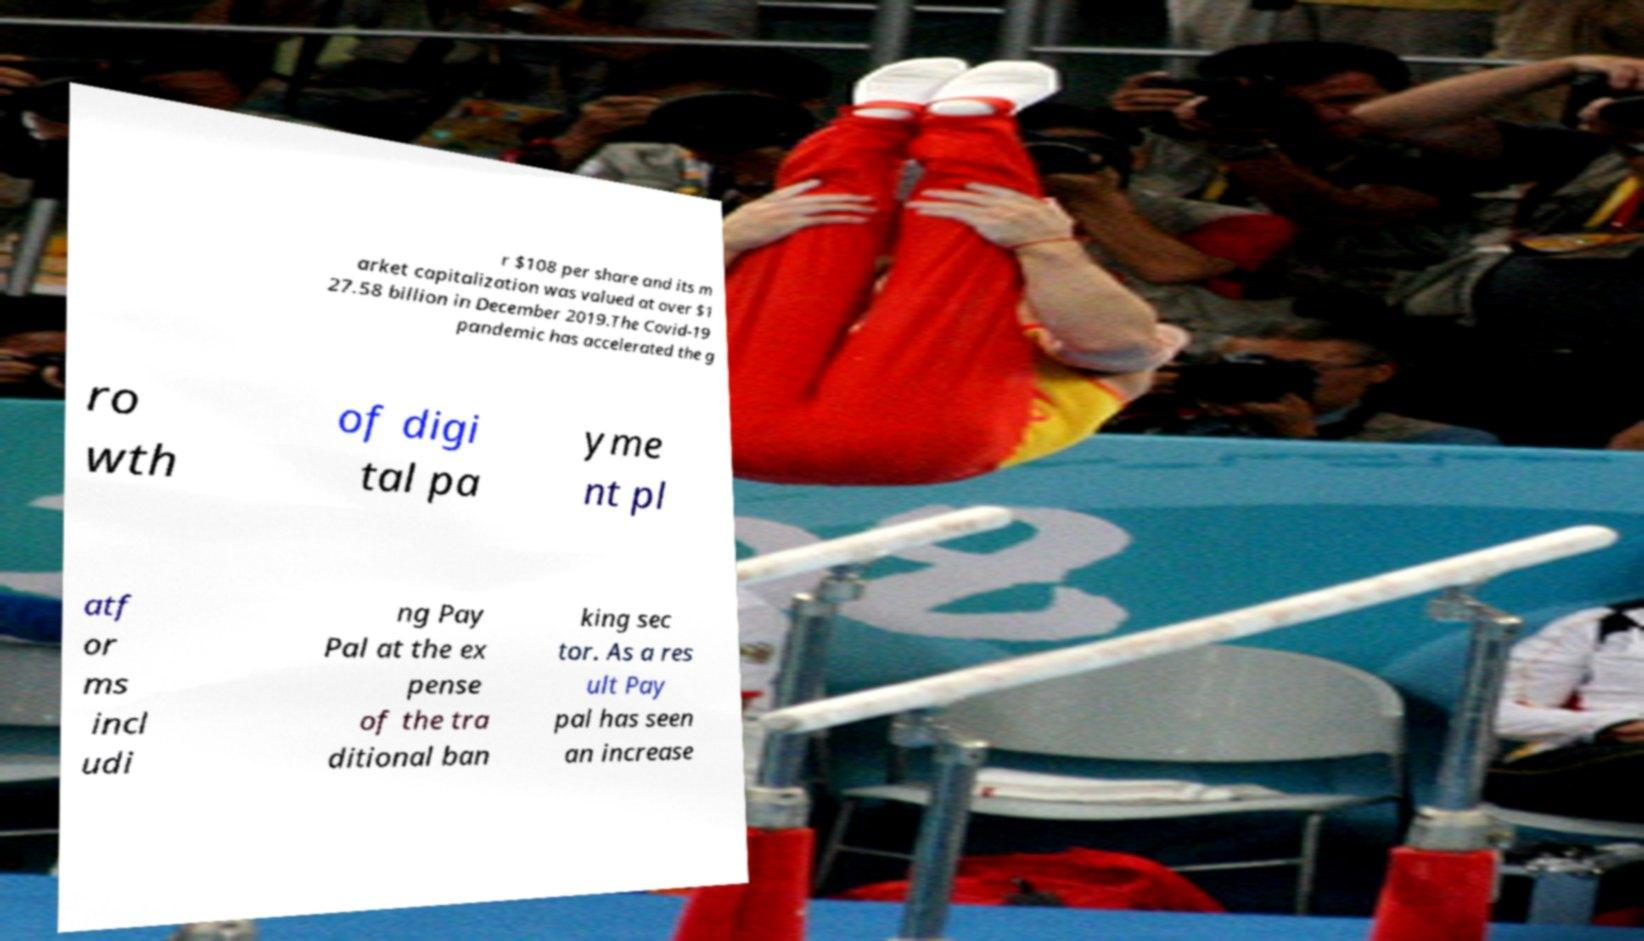What messages or text are displayed in this image? I need them in a readable, typed format. r $108 per share and its m arket capitalization was valued at over $1 27.58 billion in December 2019.The Covid-19 pandemic has accelerated the g ro wth of digi tal pa yme nt pl atf or ms incl udi ng Pay Pal at the ex pense of the tra ditional ban king sec tor. As a res ult Pay pal has seen an increase 